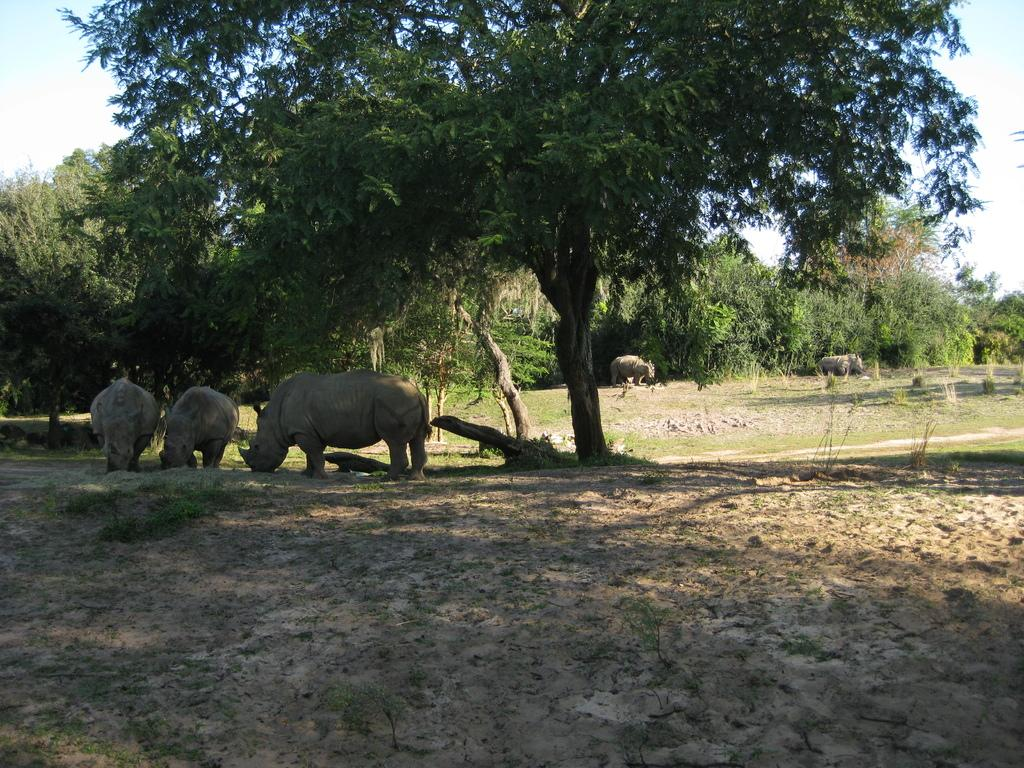What type of living organisms can be seen on the ground in the image? There are animals on the ground in the image. What can be seen in the background of the image? There are trees and the sky visible in the background of the image. How many cherries are hanging from the trees in the image? There are no cherries present in the image; it features animals on the ground and trees in the background. 